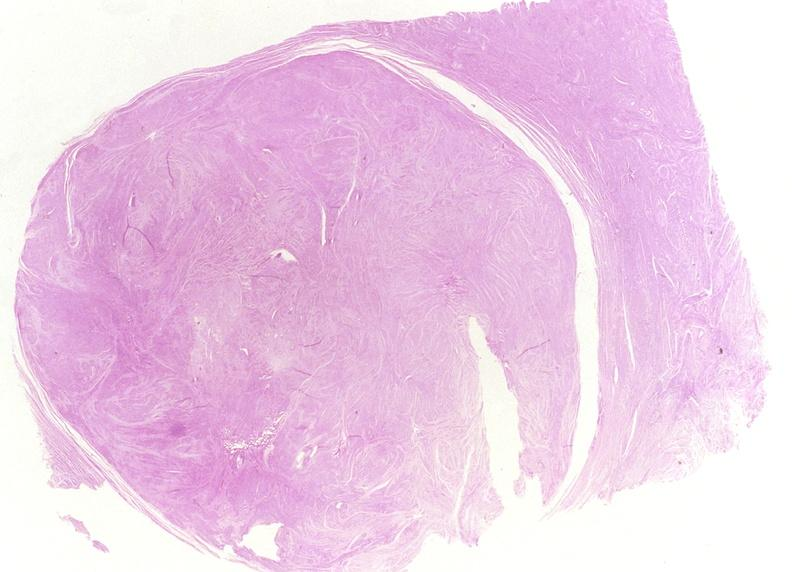does this image show leiomyoma?
Answer the question using a single word or phrase. Yes 